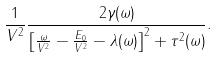<formula> <loc_0><loc_0><loc_500><loc_500>\frac { 1 } { V ^ { 2 } } \frac { 2 \gamma ( \omega ) } { \left [ \frac { \omega } { V ^ { 2 } } - \frac { E _ { 0 } } { V ^ { 2 } } - \lambda ( \omega ) \right ] ^ { 2 } + \tau ^ { 2 } ( \omega ) } .</formula> 